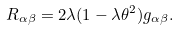<formula> <loc_0><loc_0><loc_500><loc_500>R _ { { \alpha } { \beta } } = 2 { \lambda } ( 1 - { \lambda } { \theta } ^ { 2 } ) g _ { { \alpha } { \beta } } .</formula> 